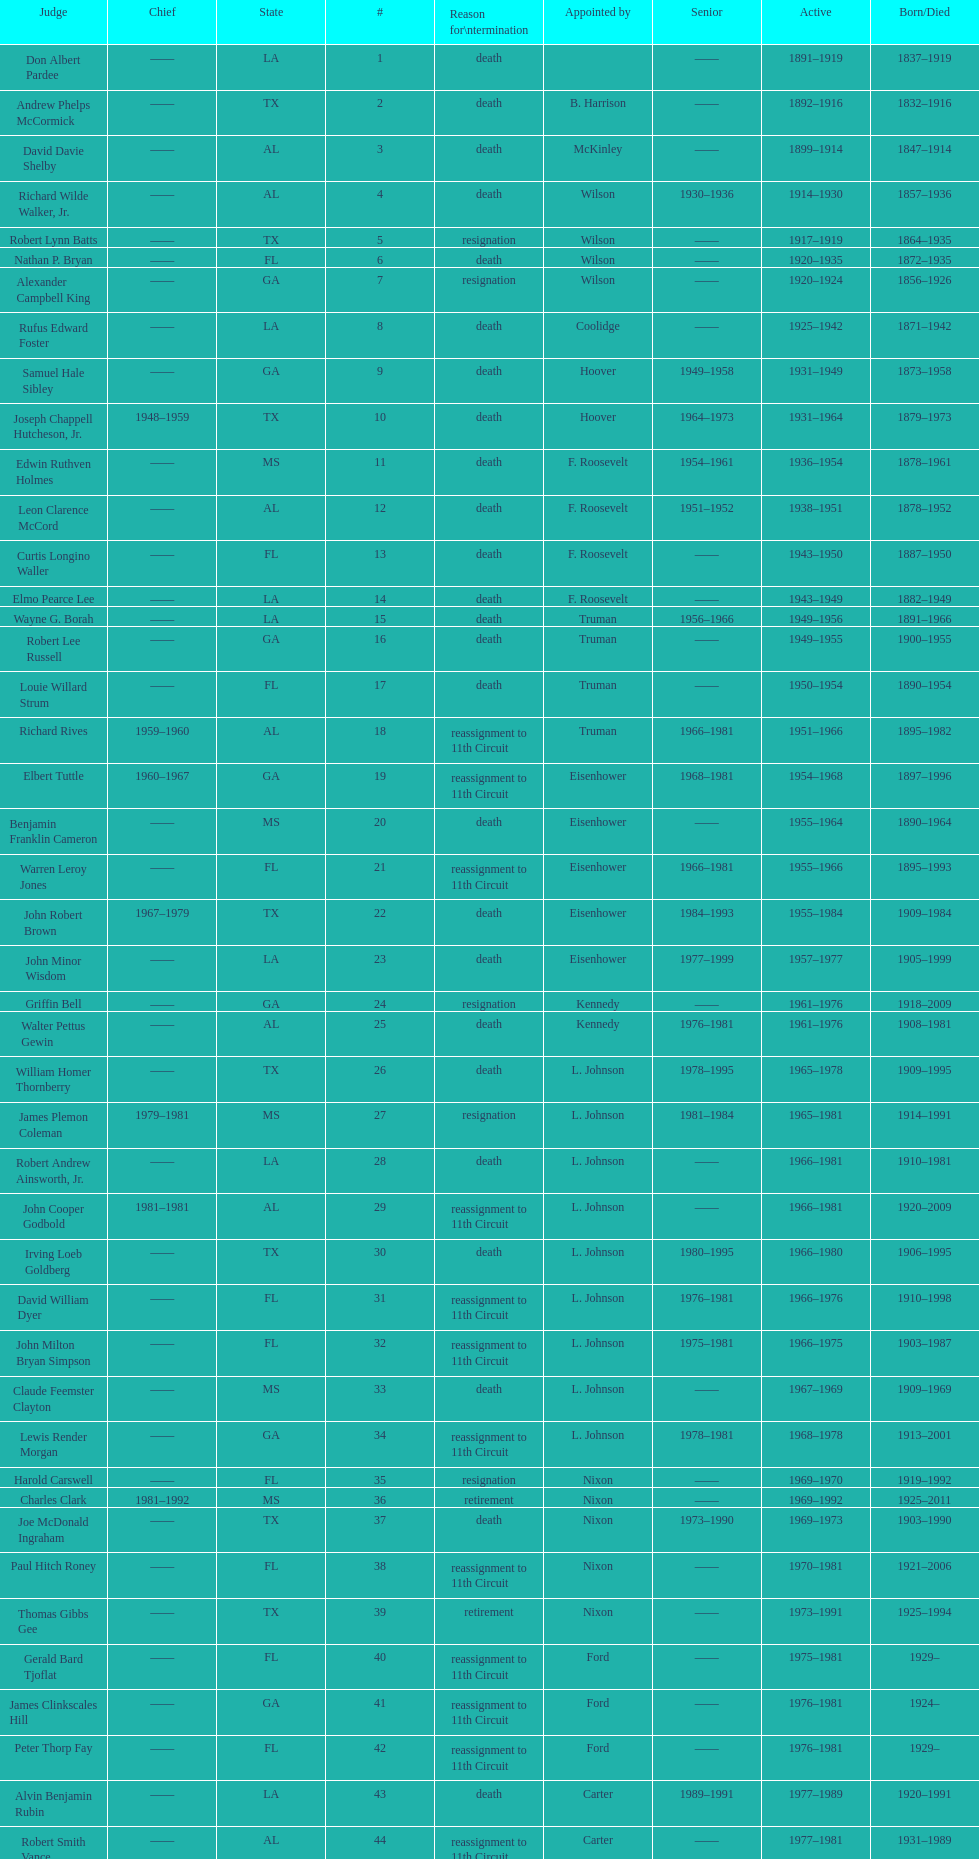How many judges were appointed by president carter? 13. 